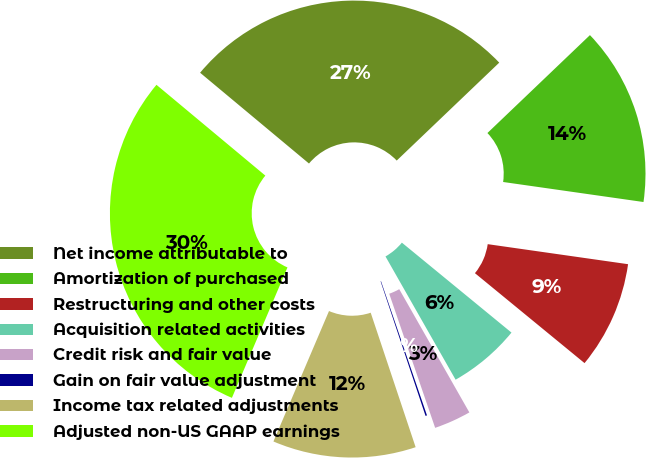Convert chart to OTSL. <chart><loc_0><loc_0><loc_500><loc_500><pie_chart><fcel>Net income attributable to<fcel>Amortization of purchased<fcel>Restructuring and other costs<fcel>Acquisition related activities<fcel>Credit risk and fair value<fcel>Gain on fair value adjustment<fcel>Income tax related adjustments<fcel>Adjusted non-US GAAP earnings<nl><fcel>26.8%<fcel>14.39%<fcel>8.68%<fcel>5.83%<fcel>2.98%<fcel>0.12%<fcel>11.54%<fcel>29.65%<nl></chart> 